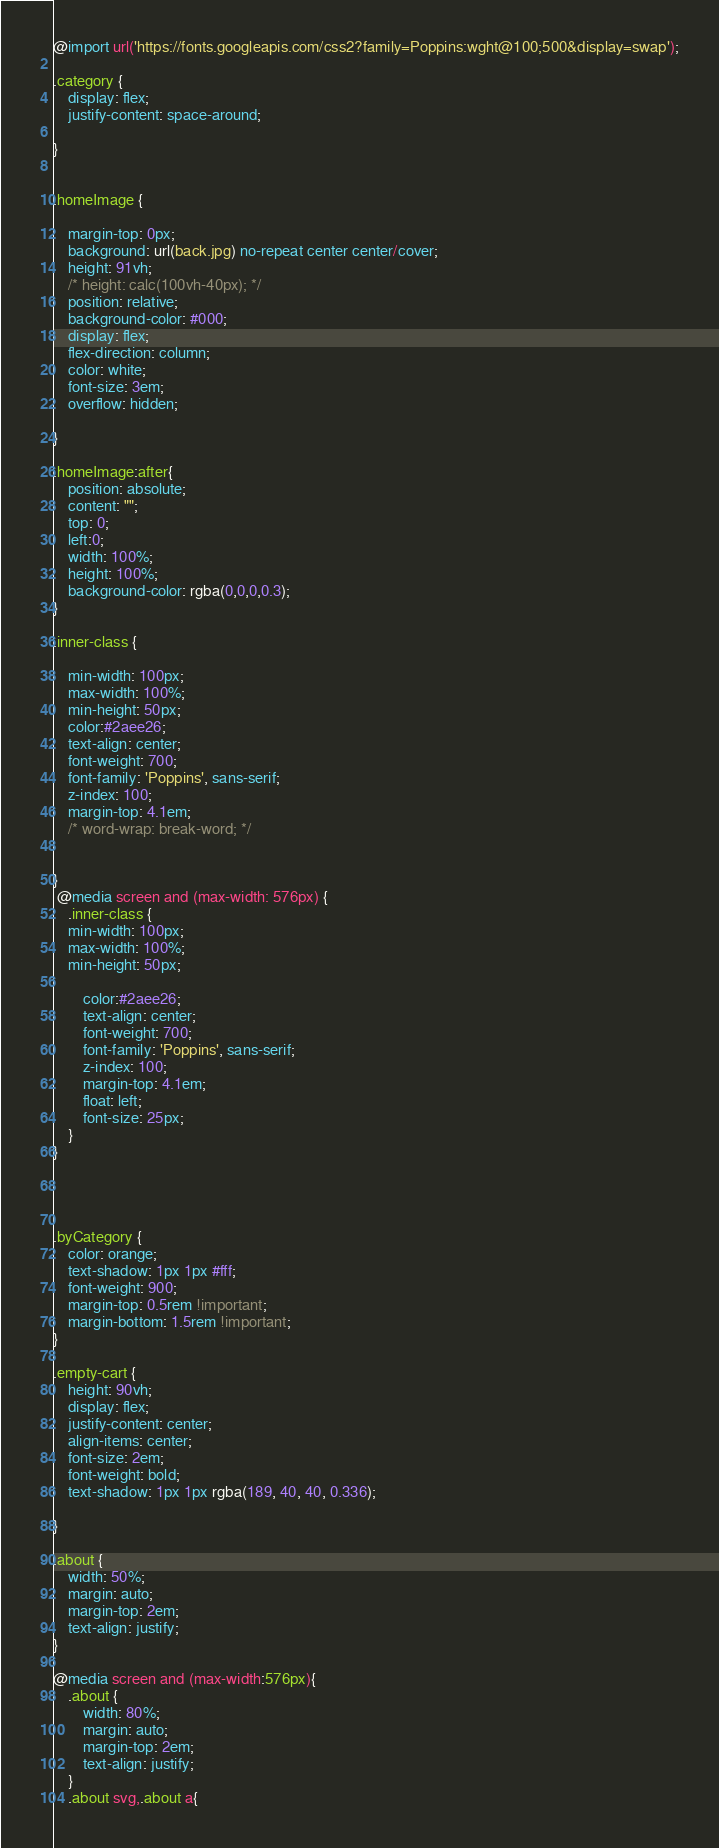Convert code to text. <code><loc_0><loc_0><loc_500><loc_500><_CSS_>@import url('https://fonts.googleapis.com/css2?family=Poppins:wght@100;500&display=swap');

.category {
    display: flex;
    justify-content: space-around;

}


.homeImage {

    margin-top: 0px;
    background: url(back.jpg) no-repeat center center/cover;
    height: 91vh;
    /* height: calc(100vh-40px); */
    position: relative;
    background-color: #000; 
    display: flex;
    flex-direction: column;
    color: white;
    font-size: 3em;
    overflow: hidden;

}

.homeImage:after{
    position: absolute;
    content: "";
    top: 0;
    left:0;
    width: 100%;
    height: 100%;
    background-color: rgba(0,0,0,0.3);
}

.inner-class {
   
    min-width: 100px;
    max-width: 100%;
    min-height: 50px;
    color:#2aee26;
    text-align: center;
    font-weight: 700;
    font-family: 'Poppins', sans-serif;
    z-index: 100;
    margin-top: 4.1em;
    /* word-wrap: break-word; */

    
}
 @media screen and (max-width: 576px) {
    .inner-class {
    min-width: 100px;
    max-width: 100%;
    min-height: 50px;
     
        color:#2aee26;
        text-align: center;
        font-weight: 700; 
        font-family: 'Poppins', sans-serif;
        z-index: 100;
        margin-top: 4.1em;
        float: left;
        font-size: 25px;
    }
}
        
    


.byCategory {
    color: orange;
    text-shadow: 1px 1px #fff;
    font-weight: 900;
    margin-top: 0.5rem !important;
    margin-bottom: 1.5rem !important;
}

.empty-cart {
    height: 90vh;
    display: flex;
    justify-content: center;
    align-items: center;
    font-size: 2em;
    font-weight: bold;
    text-shadow: 1px 1px rgba(189, 40, 40, 0.336);

}

.about {
    width: 50%;
    margin: auto;
    margin-top: 2em;
    text-align: justify;
}

@media screen and (max-width:576px){
    .about {
        width: 80%;
        margin: auto; 
        margin-top: 2em;
        text-align: justify;
    }
    .about svg,.about a{</code> 